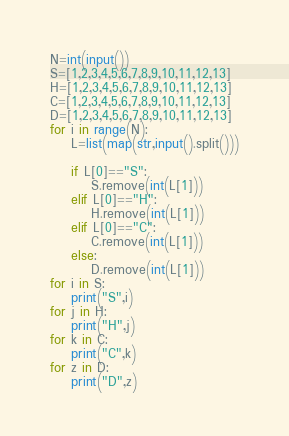Convert code to text. <code><loc_0><loc_0><loc_500><loc_500><_Python_>N=int(input())
S=[1,2,3,4,5,6,7,8,9,10,11,12,13]
H=[1,2,3,4,5,6,7,8,9,10,11,12,13]
C=[1,2,3,4,5,6,7,8,9,10,11,12,13]
D=[1,2,3,4,5,6,7,8,9,10,11,12,13]
for i in range(N):
    L=list(map(str,input().split()))
    
    if L[0]=="S":
        S.remove(int(L[1]))
    elif L[0]=="H":
        H.remove(int(L[1]))
    elif L[0]=="C":
        C.remove(int(L[1]))
    else:
        D.remove(int(L[1]))
for i in S:
    print("S",i)
for j in H:
    print("H",j)
for k in C:
    print("C",k)
for z in D:
    print("D",z)

</code> 